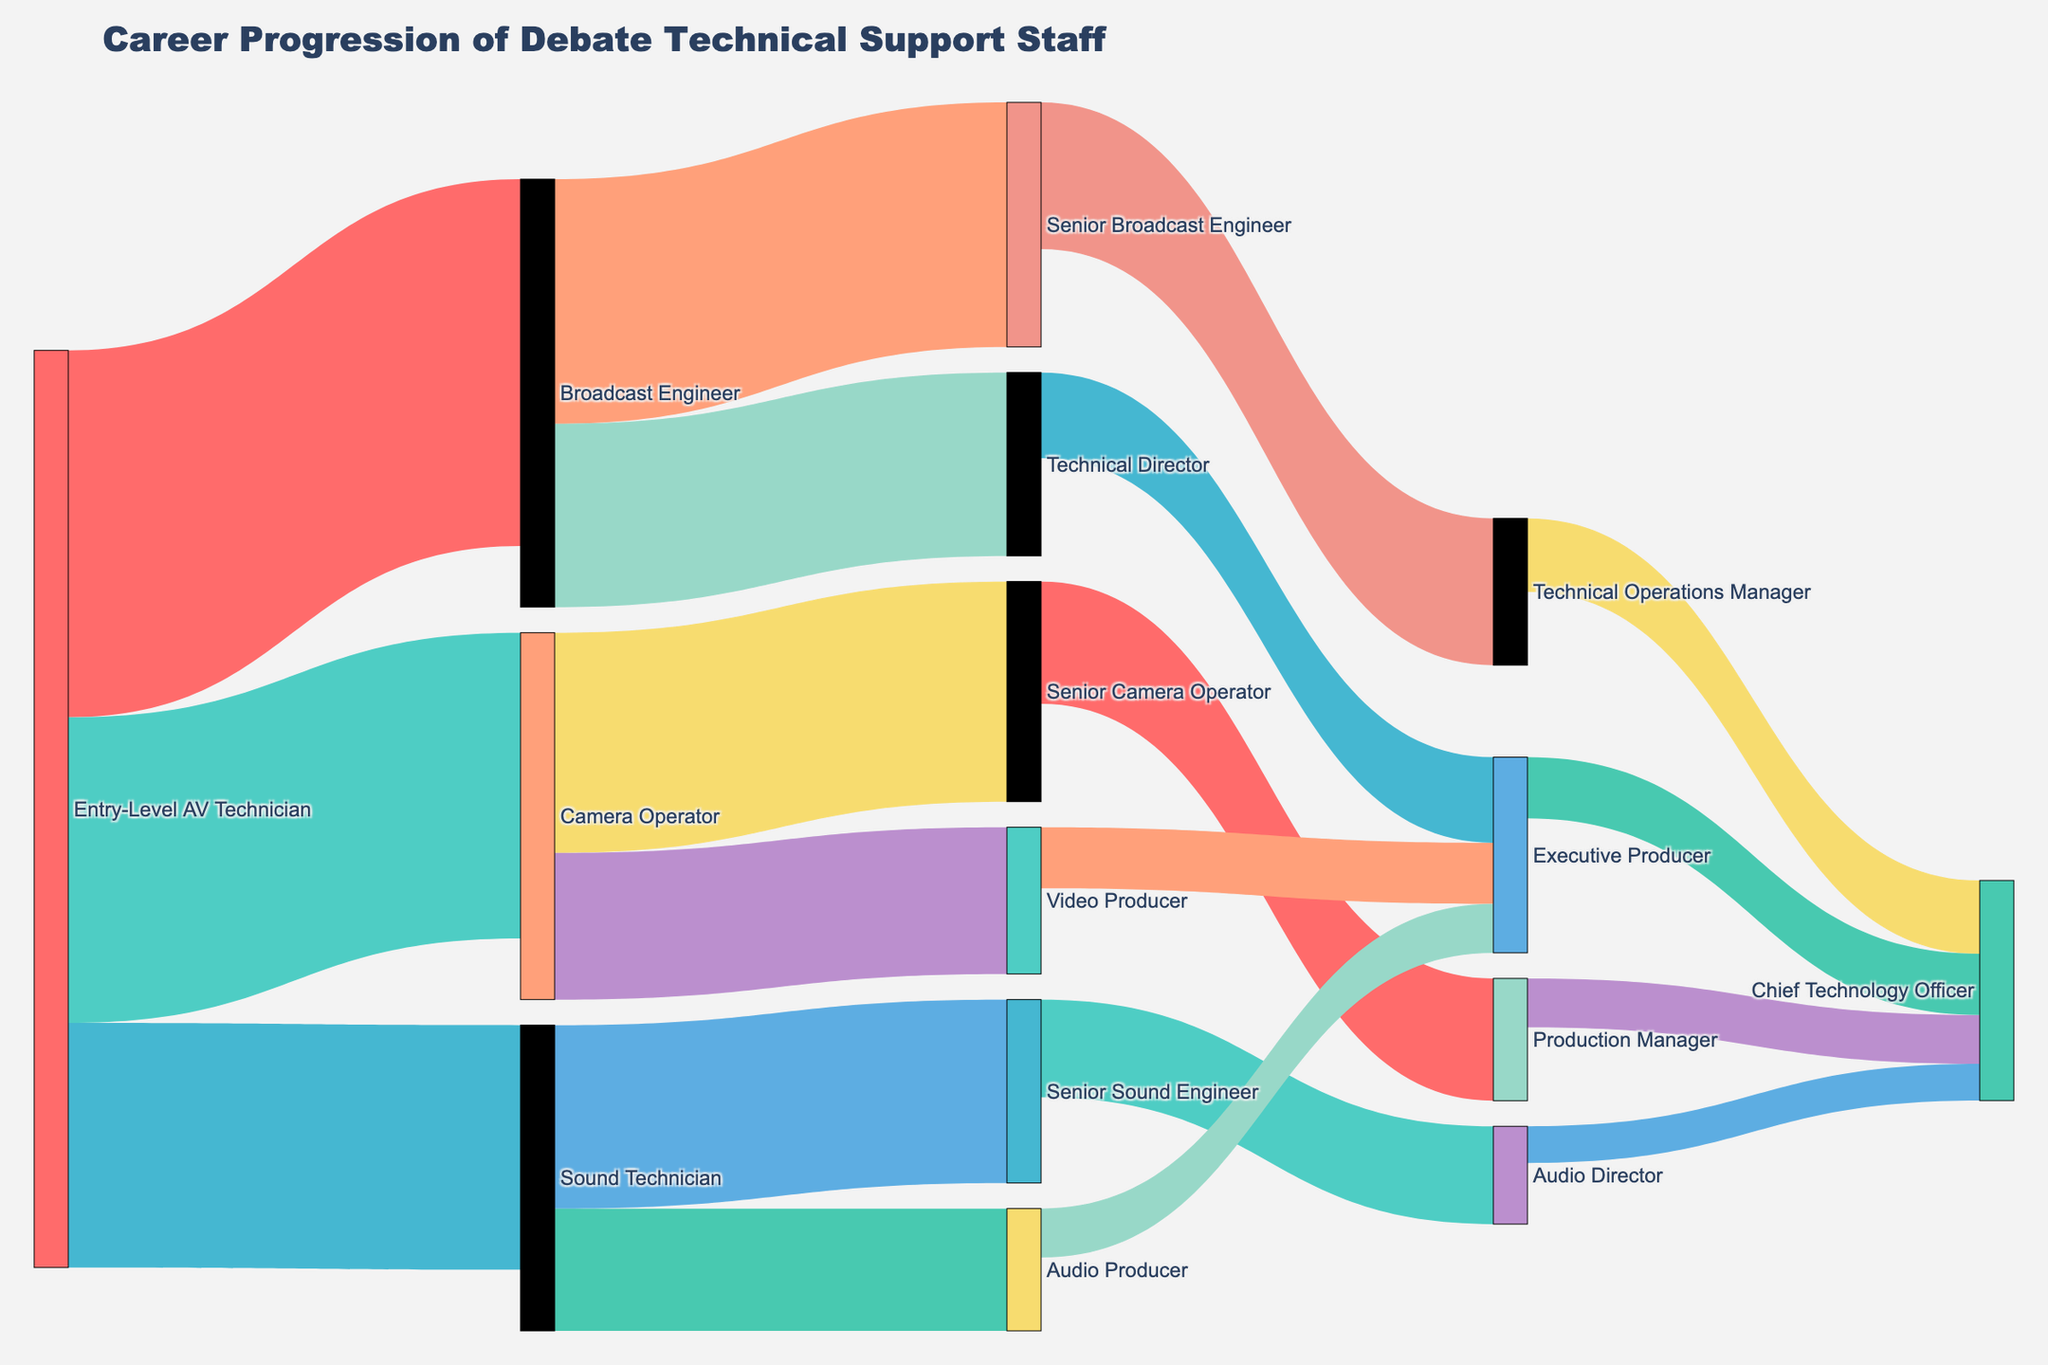What's the title of the figure? The title is prominently displayed at the top of the figure.
Answer: Career Progression of Debate Technical Support Staff How many career paths lead to the Chief Technology Officer position? Identify all unique source-target pairs that culminate in the Chief Technology Officer position. Each unique source contributing to the target counts as one path.
Answer: 4 What's the total number of individuals that transition from a Senior position to an Executive Producer? Add the values for all paths leading from any Senior position to Executive Producer.
Answer: 16 (7 from Technical Director, 5 from Video Producer, and 4 from Audio Producer) How does the number of individuals moving from Broadcast Engineer to Technical Director compare to those moving from Sound Technician to Senior Sound Engineer? Compare the two transition values in question. Broadcast Engineer to Technical Director: 15, Sound Technician to Senior Sound Engineer: 15.
Answer: Equal Which position has the highest number of incoming transitions? Sum up all values transitioning into each target position and identify the position with the highest sum.
Answer: Executive Producer How many individuals start their career as Entry-Level AV Technician? Sum all the values originating from Entry-Level AV Technician.
Answer: 75 From the Senior positions, which path has the smallest flow value toward an Executive level? Identify all flows from Senior positions to Executive levels and find the smallest one.
Answer: Audio Producer to Executive Producer What is the total number of individuals that progress from any position to an Executive Producer? Sum the values of all paths leading to the Executive Producer position.
Answer: 16 Which transition has the highest flow value in the diagram? Identify the path with the highest value among all source-target pairs.
Answer: Entry-Level AV Technician to Broadcast Engineer What is the ratio of individuals moving from Camera Operator to Senior Camera Operator versus those moving from Camera Operator to Video Producer? Divide the value of the transition from Camera Operator to Senior Camera Operator by the value of the transition from Camera Operator to Video Producer.
Answer: 18/12 or 1.5 